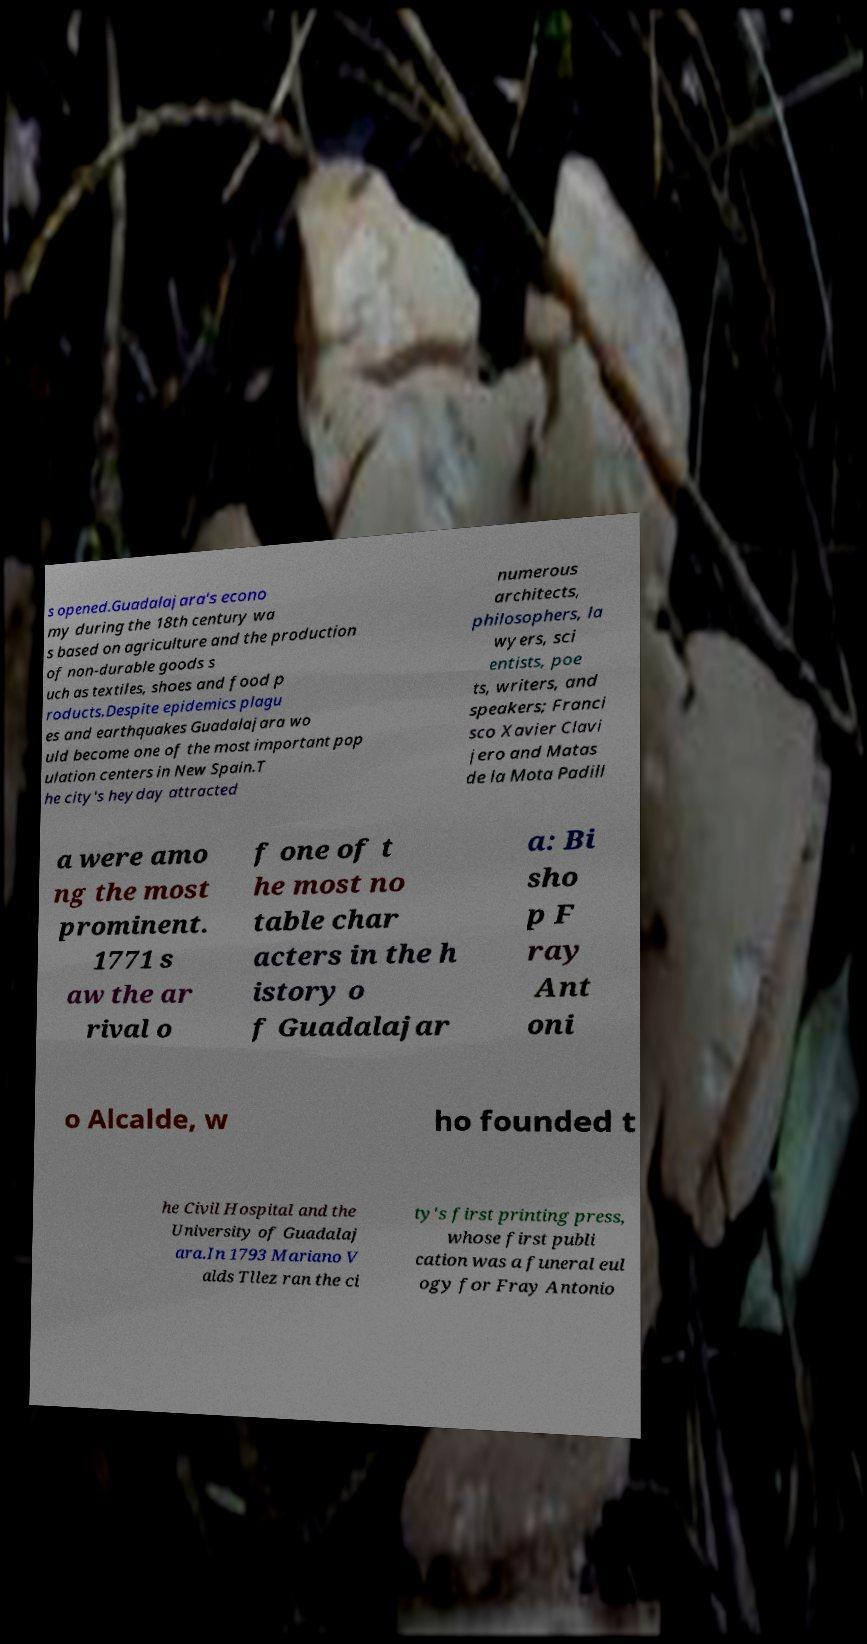Can you read and provide the text displayed in the image?This photo seems to have some interesting text. Can you extract and type it out for me? s opened.Guadalajara's econo my during the 18th century wa s based on agriculture and the production of non-durable goods s uch as textiles, shoes and food p roducts.Despite epidemics plagu es and earthquakes Guadalajara wo uld become one of the most important pop ulation centers in New Spain.T he city's heyday attracted numerous architects, philosophers, la wyers, sci entists, poe ts, writers, and speakers; Franci sco Xavier Clavi jero and Matas de la Mota Padill a were amo ng the most prominent. 1771 s aw the ar rival o f one of t he most no table char acters in the h istory o f Guadalajar a: Bi sho p F ray Ant oni o Alcalde, w ho founded t he Civil Hospital and the University of Guadalaj ara.In 1793 Mariano V alds Tllez ran the ci ty's first printing press, whose first publi cation was a funeral eul ogy for Fray Antonio 